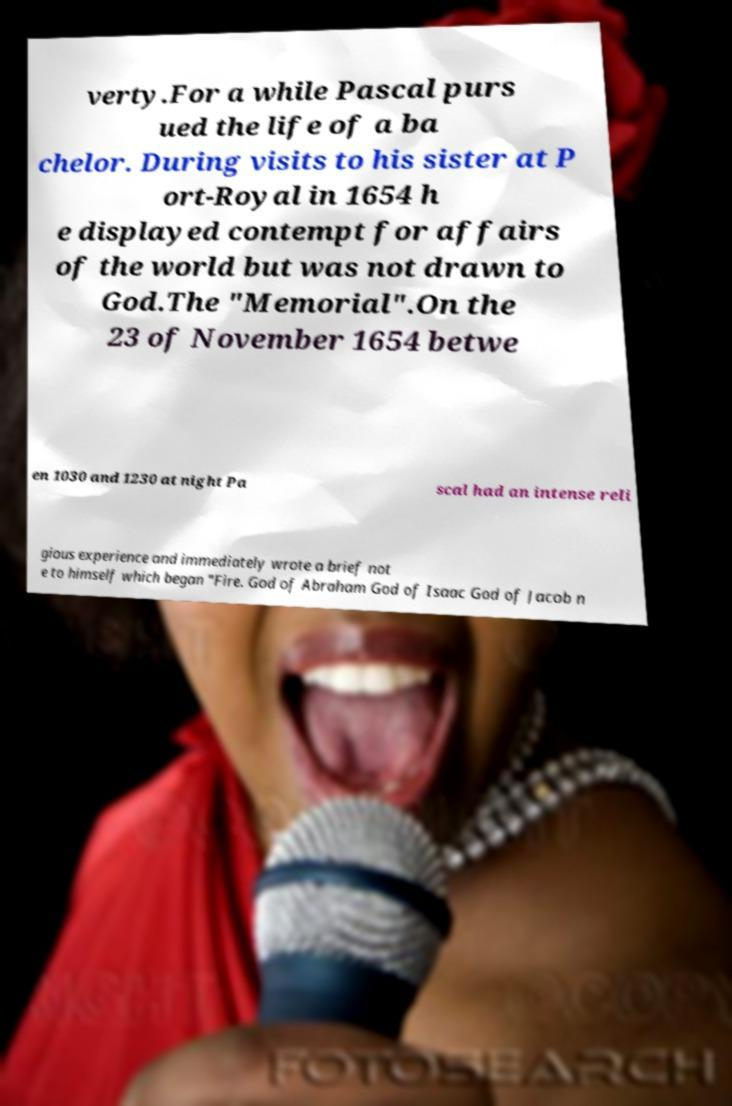Can you read and provide the text displayed in the image?This photo seems to have some interesting text. Can you extract and type it out for me? verty.For a while Pascal purs ued the life of a ba chelor. During visits to his sister at P ort-Royal in 1654 h e displayed contempt for affairs of the world but was not drawn to God.The "Memorial".On the 23 of November 1654 betwe en 1030 and 1230 at night Pa scal had an intense reli gious experience and immediately wrote a brief not e to himself which began "Fire. God of Abraham God of Isaac God of Jacob n 